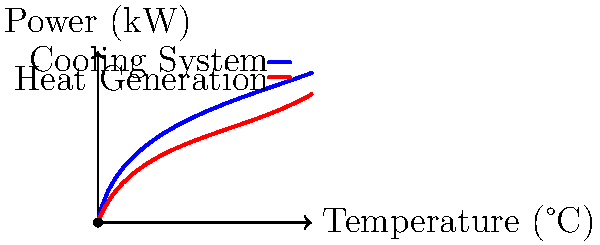In an electric racing car, the motor's heat generation increases with power output, while the cooling system's efficiency also improves at higher temperatures. Given the heat generation (red) and cooling system efficiency (blue) curves in the graph, at what power output does the cooling system's capacity match the motor's heat generation, ensuring optimal performance without overheating? To find the power output where the cooling system's capacity matches the motor's heat generation, we need to analyze the graph step-by-step:

1. The red curve represents the motor's heat generation as a function of power output.
2. The blue curve shows the cooling system's efficiency as temperature increases.
3. The point where these two curves intersect is the equilibrium point we're looking for.
4. At this intersection point, the cooling system's capacity exactly matches the heat generated by the motor.
5. To find the power output at this point, we need to read the x-coordinate of the intersection.
6. From the graph, we can see that the intersection occurs at approximately 7.5 kW on the x-axis.

This power output represents the optimal balance between performance and cooling efficiency. At this point:

- The motor generates heat at a rate that the cooling system can handle effectively.
- The cooling system operates at its most efficient temperature for that power output.
- The car can maintain this power output sustainably without risk of overheating.

Operating beyond this point would risk overheating the motor, while operating below it would not fully utilize the cooling system's capacity.
Answer: 7.5 kW 